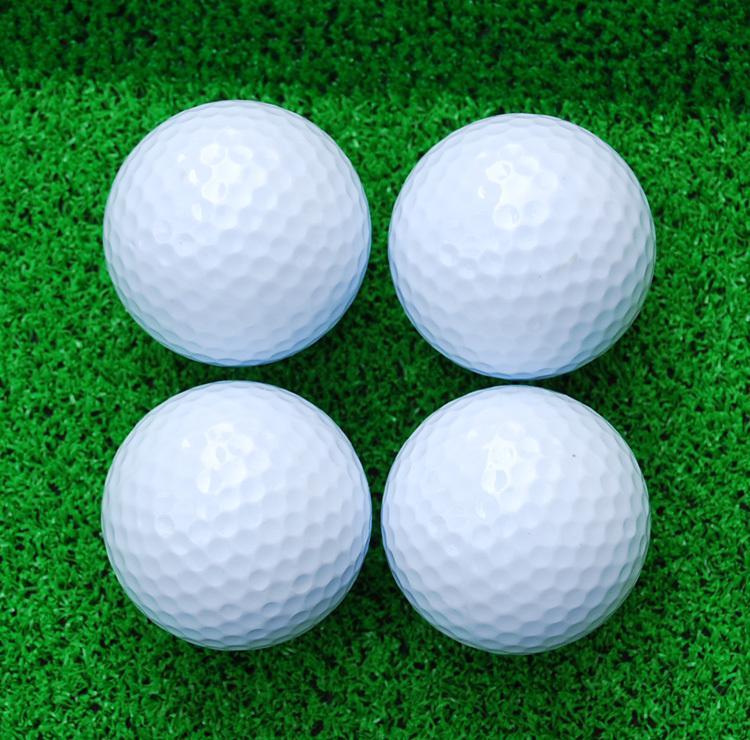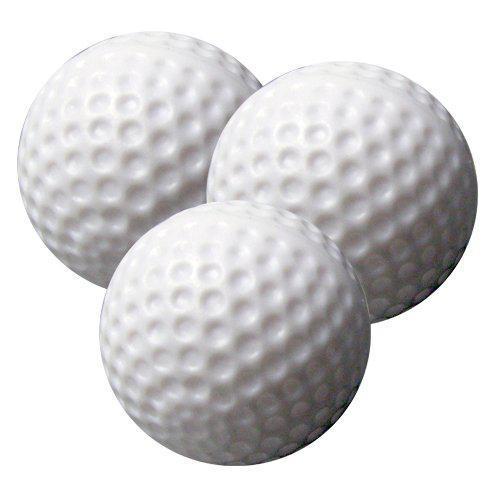The first image is the image on the left, the second image is the image on the right. Evaluate the accuracy of this statement regarding the images: "At least one of the images do not contain grass.". Is it true? Answer yes or no. Yes. The first image is the image on the left, the second image is the image on the right. For the images displayed, is the sentence "Both images show golf balls on a grass-type background." factually correct? Answer yes or no. No. The first image is the image on the left, the second image is the image on the right. Considering the images on both sides, is "There is one golf ball sitting on top of other balls in the image on the right." valid? Answer yes or no. No. 